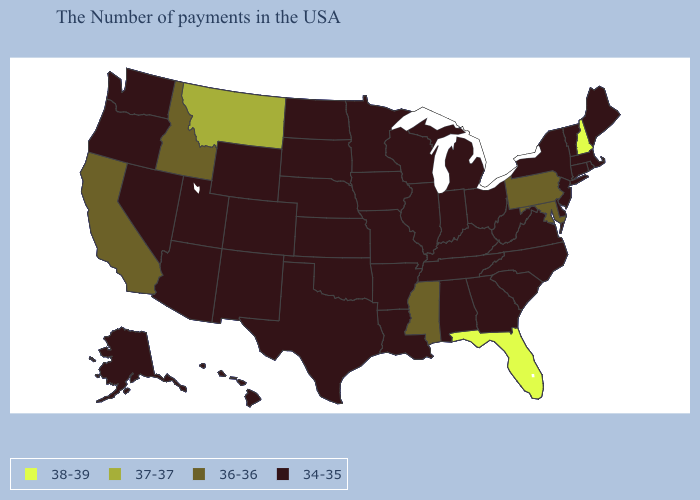What is the value of South Dakota?
Write a very short answer. 34-35. Which states hav the highest value in the South?
Keep it brief. Florida. What is the lowest value in the Northeast?
Short answer required. 34-35. What is the lowest value in the USA?
Be succinct. 34-35. What is the value of Delaware?
Be succinct. 34-35. Which states have the highest value in the USA?
Be succinct. New Hampshire, Florida. Name the states that have a value in the range 36-36?
Be succinct. Maryland, Pennsylvania, Mississippi, Idaho, California. How many symbols are there in the legend?
Be succinct. 4. What is the highest value in the West ?
Give a very brief answer. 37-37. Among the states that border North Dakota , which have the highest value?
Be succinct. Montana. Name the states that have a value in the range 34-35?
Concise answer only. Maine, Massachusetts, Rhode Island, Vermont, Connecticut, New York, New Jersey, Delaware, Virginia, North Carolina, South Carolina, West Virginia, Ohio, Georgia, Michigan, Kentucky, Indiana, Alabama, Tennessee, Wisconsin, Illinois, Louisiana, Missouri, Arkansas, Minnesota, Iowa, Kansas, Nebraska, Oklahoma, Texas, South Dakota, North Dakota, Wyoming, Colorado, New Mexico, Utah, Arizona, Nevada, Washington, Oregon, Alaska, Hawaii. Name the states that have a value in the range 36-36?
Give a very brief answer. Maryland, Pennsylvania, Mississippi, Idaho, California. Does Wisconsin have a lower value than Florida?
Concise answer only. Yes. What is the value of New Hampshire?
Give a very brief answer. 38-39. 